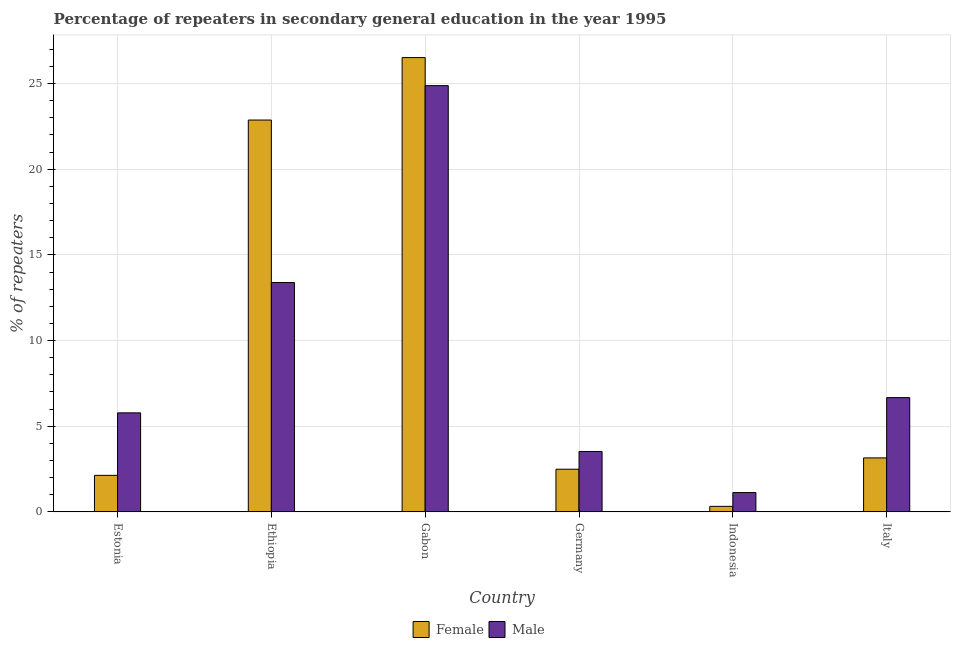Are the number of bars on each tick of the X-axis equal?
Your answer should be very brief. Yes. How many bars are there on the 5th tick from the right?
Give a very brief answer. 2. What is the label of the 6th group of bars from the left?
Keep it short and to the point. Italy. In how many cases, is the number of bars for a given country not equal to the number of legend labels?
Your answer should be compact. 0. What is the percentage of female repeaters in Ethiopia?
Keep it short and to the point. 22.87. Across all countries, what is the maximum percentage of female repeaters?
Provide a succinct answer. 26.52. Across all countries, what is the minimum percentage of male repeaters?
Offer a terse response. 1.13. In which country was the percentage of male repeaters maximum?
Ensure brevity in your answer.  Gabon. In which country was the percentage of female repeaters minimum?
Ensure brevity in your answer.  Indonesia. What is the total percentage of male repeaters in the graph?
Offer a terse response. 55.37. What is the difference between the percentage of female repeaters in Gabon and that in Germany?
Offer a terse response. 24.03. What is the difference between the percentage of male repeaters in Italy and the percentage of female repeaters in Indonesia?
Give a very brief answer. 6.35. What is the average percentage of male repeaters per country?
Offer a terse response. 9.23. What is the difference between the percentage of male repeaters and percentage of female repeaters in Italy?
Keep it short and to the point. 3.52. In how many countries, is the percentage of female repeaters greater than 24 %?
Provide a short and direct response. 1. What is the ratio of the percentage of male repeaters in Ethiopia to that in Gabon?
Your answer should be compact. 0.54. Is the difference between the percentage of male repeaters in Ethiopia and Germany greater than the difference between the percentage of female repeaters in Ethiopia and Germany?
Make the answer very short. No. What is the difference between the highest and the second highest percentage of female repeaters?
Your response must be concise. 3.65. What is the difference between the highest and the lowest percentage of female repeaters?
Offer a terse response. 26.19. Is the sum of the percentage of female repeaters in Estonia and Gabon greater than the maximum percentage of male repeaters across all countries?
Offer a terse response. Yes. What is the difference between two consecutive major ticks on the Y-axis?
Give a very brief answer. 5. Are the values on the major ticks of Y-axis written in scientific E-notation?
Your response must be concise. No. Does the graph contain any zero values?
Make the answer very short. No. Does the graph contain grids?
Your answer should be very brief. Yes. Where does the legend appear in the graph?
Offer a very short reply. Bottom center. How many legend labels are there?
Make the answer very short. 2. What is the title of the graph?
Ensure brevity in your answer.  Percentage of repeaters in secondary general education in the year 1995. Does "Domestic liabilities" appear as one of the legend labels in the graph?
Keep it short and to the point. No. What is the label or title of the Y-axis?
Make the answer very short. % of repeaters. What is the % of repeaters of Female in Estonia?
Your answer should be compact. 2.13. What is the % of repeaters in Male in Estonia?
Provide a short and direct response. 5.78. What is the % of repeaters in Female in Ethiopia?
Ensure brevity in your answer.  22.87. What is the % of repeaters of Male in Ethiopia?
Your answer should be very brief. 13.39. What is the % of repeaters in Female in Gabon?
Your answer should be compact. 26.52. What is the % of repeaters of Male in Gabon?
Keep it short and to the point. 24.88. What is the % of repeaters in Female in Germany?
Provide a succinct answer. 2.49. What is the % of repeaters in Male in Germany?
Keep it short and to the point. 3.52. What is the % of repeaters in Female in Indonesia?
Your response must be concise. 0.32. What is the % of repeaters in Male in Indonesia?
Ensure brevity in your answer.  1.13. What is the % of repeaters in Female in Italy?
Ensure brevity in your answer.  3.15. What is the % of repeaters of Male in Italy?
Offer a terse response. 6.67. Across all countries, what is the maximum % of repeaters of Female?
Your response must be concise. 26.52. Across all countries, what is the maximum % of repeaters in Male?
Your response must be concise. 24.88. Across all countries, what is the minimum % of repeaters of Female?
Your response must be concise. 0.32. Across all countries, what is the minimum % of repeaters of Male?
Provide a short and direct response. 1.13. What is the total % of repeaters in Female in the graph?
Keep it short and to the point. 57.48. What is the total % of repeaters of Male in the graph?
Make the answer very short. 55.37. What is the difference between the % of repeaters of Female in Estonia and that in Ethiopia?
Your response must be concise. -20.74. What is the difference between the % of repeaters of Male in Estonia and that in Ethiopia?
Ensure brevity in your answer.  -7.61. What is the difference between the % of repeaters in Female in Estonia and that in Gabon?
Provide a succinct answer. -24.38. What is the difference between the % of repeaters in Male in Estonia and that in Gabon?
Provide a short and direct response. -19.1. What is the difference between the % of repeaters of Female in Estonia and that in Germany?
Give a very brief answer. -0.36. What is the difference between the % of repeaters of Male in Estonia and that in Germany?
Provide a succinct answer. 2.26. What is the difference between the % of repeaters of Female in Estonia and that in Indonesia?
Your response must be concise. 1.81. What is the difference between the % of repeaters in Male in Estonia and that in Indonesia?
Your answer should be compact. 4.65. What is the difference between the % of repeaters in Female in Estonia and that in Italy?
Provide a short and direct response. -1.02. What is the difference between the % of repeaters of Male in Estonia and that in Italy?
Offer a terse response. -0.89. What is the difference between the % of repeaters in Female in Ethiopia and that in Gabon?
Provide a short and direct response. -3.65. What is the difference between the % of repeaters in Male in Ethiopia and that in Gabon?
Give a very brief answer. -11.49. What is the difference between the % of repeaters in Female in Ethiopia and that in Germany?
Provide a succinct answer. 20.38. What is the difference between the % of repeaters in Male in Ethiopia and that in Germany?
Your response must be concise. 9.86. What is the difference between the % of repeaters in Female in Ethiopia and that in Indonesia?
Offer a very short reply. 22.55. What is the difference between the % of repeaters in Male in Ethiopia and that in Indonesia?
Keep it short and to the point. 12.26. What is the difference between the % of repeaters in Female in Ethiopia and that in Italy?
Provide a short and direct response. 19.72. What is the difference between the % of repeaters of Male in Ethiopia and that in Italy?
Offer a terse response. 6.72. What is the difference between the % of repeaters in Female in Gabon and that in Germany?
Provide a short and direct response. 24.03. What is the difference between the % of repeaters in Male in Gabon and that in Germany?
Keep it short and to the point. 21.35. What is the difference between the % of repeaters of Female in Gabon and that in Indonesia?
Ensure brevity in your answer.  26.19. What is the difference between the % of repeaters of Male in Gabon and that in Indonesia?
Provide a succinct answer. 23.75. What is the difference between the % of repeaters in Female in Gabon and that in Italy?
Make the answer very short. 23.36. What is the difference between the % of repeaters in Male in Gabon and that in Italy?
Your answer should be compact. 18.21. What is the difference between the % of repeaters in Female in Germany and that in Indonesia?
Make the answer very short. 2.17. What is the difference between the % of repeaters of Male in Germany and that in Indonesia?
Provide a short and direct response. 2.4. What is the difference between the % of repeaters in Female in Germany and that in Italy?
Keep it short and to the point. -0.66. What is the difference between the % of repeaters of Male in Germany and that in Italy?
Make the answer very short. -3.14. What is the difference between the % of repeaters in Female in Indonesia and that in Italy?
Make the answer very short. -2.83. What is the difference between the % of repeaters of Male in Indonesia and that in Italy?
Provide a succinct answer. -5.54. What is the difference between the % of repeaters in Female in Estonia and the % of repeaters in Male in Ethiopia?
Offer a terse response. -11.25. What is the difference between the % of repeaters in Female in Estonia and the % of repeaters in Male in Gabon?
Your answer should be compact. -22.75. What is the difference between the % of repeaters of Female in Estonia and the % of repeaters of Male in Germany?
Keep it short and to the point. -1.39. What is the difference between the % of repeaters in Female in Estonia and the % of repeaters in Male in Indonesia?
Keep it short and to the point. 1. What is the difference between the % of repeaters of Female in Estonia and the % of repeaters of Male in Italy?
Offer a very short reply. -4.54. What is the difference between the % of repeaters of Female in Ethiopia and the % of repeaters of Male in Gabon?
Offer a terse response. -2.01. What is the difference between the % of repeaters of Female in Ethiopia and the % of repeaters of Male in Germany?
Keep it short and to the point. 19.35. What is the difference between the % of repeaters in Female in Ethiopia and the % of repeaters in Male in Indonesia?
Offer a very short reply. 21.74. What is the difference between the % of repeaters in Female in Ethiopia and the % of repeaters in Male in Italy?
Provide a succinct answer. 16.2. What is the difference between the % of repeaters in Female in Gabon and the % of repeaters in Male in Germany?
Provide a short and direct response. 22.99. What is the difference between the % of repeaters in Female in Gabon and the % of repeaters in Male in Indonesia?
Your answer should be compact. 25.39. What is the difference between the % of repeaters of Female in Gabon and the % of repeaters of Male in Italy?
Your answer should be very brief. 19.85. What is the difference between the % of repeaters in Female in Germany and the % of repeaters in Male in Indonesia?
Make the answer very short. 1.36. What is the difference between the % of repeaters of Female in Germany and the % of repeaters of Male in Italy?
Make the answer very short. -4.18. What is the difference between the % of repeaters in Female in Indonesia and the % of repeaters in Male in Italy?
Your answer should be very brief. -6.35. What is the average % of repeaters in Female per country?
Your answer should be very brief. 9.58. What is the average % of repeaters of Male per country?
Ensure brevity in your answer.  9.23. What is the difference between the % of repeaters of Female and % of repeaters of Male in Estonia?
Your answer should be compact. -3.65. What is the difference between the % of repeaters in Female and % of repeaters in Male in Ethiopia?
Keep it short and to the point. 9.48. What is the difference between the % of repeaters in Female and % of repeaters in Male in Gabon?
Make the answer very short. 1.64. What is the difference between the % of repeaters of Female and % of repeaters of Male in Germany?
Your answer should be compact. -1.03. What is the difference between the % of repeaters of Female and % of repeaters of Male in Indonesia?
Make the answer very short. -0.81. What is the difference between the % of repeaters of Female and % of repeaters of Male in Italy?
Provide a short and direct response. -3.52. What is the ratio of the % of repeaters in Female in Estonia to that in Ethiopia?
Offer a terse response. 0.09. What is the ratio of the % of repeaters of Male in Estonia to that in Ethiopia?
Make the answer very short. 0.43. What is the ratio of the % of repeaters in Female in Estonia to that in Gabon?
Offer a very short reply. 0.08. What is the ratio of the % of repeaters of Male in Estonia to that in Gabon?
Your answer should be compact. 0.23. What is the ratio of the % of repeaters in Female in Estonia to that in Germany?
Give a very brief answer. 0.86. What is the ratio of the % of repeaters of Male in Estonia to that in Germany?
Your answer should be compact. 1.64. What is the ratio of the % of repeaters of Female in Estonia to that in Indonesia?
Make the answer very short. 6.62. What is the ratio of the % of repeaters in Male in Estonia to that in Indonesia?
Keep it short and to the point. 5.12. What is the ratio of the % of repeaters in Female in Estonia to that in Italy?
Give a very brief answer. 0.68. What is the ratio of the % of repeaters of Male in Estonia to that in Italy?
Provide a succinct answer. 0.87. What is the ratio of the % of repeaters in Female in Ethiopia to that in Gabon?
Provide a succinct answer. 0.86. What is the ratio of the % of repeaters in Male in Ethiopia to that in Gabon?
Ensure brevity in your answer.  0.54. What is the ratio of the % of repeaters in Female in Ethiopia to that in Germany?
Make the answer very short. 9.18. What is the ratio of the % of repeaters in Male in Ethiopia to that in Germany?
Your answer should be very brief. 3.8. What is the ratio of the % of repeaters of Female in Ethiopia to that in Indonesia?
Offer a terse response. 71.04. What is the ratio of the % of repeaters in Male in Ethiopia to that in Indonesia?
Ensure brevity in your answer.  11.87. What is the ratio of the % of repeaters of Female in Ethiopia to that in Italy?
Make the answer very short. 7.26. What is the ratio of the % of repeaters in Male in Ethiopia to that in Italy?
Offer a very short reply. 2.01. What is the ratio of the % of repeaters of Female in Gabon to that in Germany?
Make the answer very short. 10.65. What is the ratio of the % of repeaters of Male in Gabon to that in Germany?
Provide a short and direct response. 7.06. What is the ratio of the % of repeaters of Female in Gabon to that in Indonesia?
Your answer should be compact. 82.37. What is the ratio of the % of repeaters of Male in Gabon to that in Indonesia?
Offer a terse response. 22.06. What is the ratio of the % of repeaters of Female in Gabon to that in Italy?
Your answer should be compact. 8.42. What is the ratio of the % of repeaters in Male in Gabon to that in Italy?
Offer a very short reply. 3.73. What is the ratio of the % of repeaters in Female in Germany to that in Indonesia?
Your answer should be very brief. 7.74. What is the ratio of the % of repeaters in Male in Germany to that in Indonesia?
Offer a terse response. 3.13. What is the ratio of the % of repeaters of Female in Germany to that in Italy?
Your answer should be very brief. 0.79. What is the ratio of the % of repeaters in Male in Germany to that in Italy?
Your answer should be compact. 0.53. What is the ratio of the % of repeaters of Female in Indonesia to that in Italy?
Provide a succinct answer. 0.1. What is the ratio of the % of repeaters of Male in Indonesia to that in Italy?
Your answer should be very brief. 0.17. What is the difference between the highest and the second highest % of repeaters in Female?
Provide a short and direct response. 3.65. What is the difference between the highest and the second highest % of repeaters in Male?
Offer a terse response. 11.49. What is the difference between the highest and the lowest % of repeaters in Female?
Keep it short and to the point. 26.19. What is the difference between the highest and the lowest % of repeaters in Male?
Make the answer very short. 23.75. 